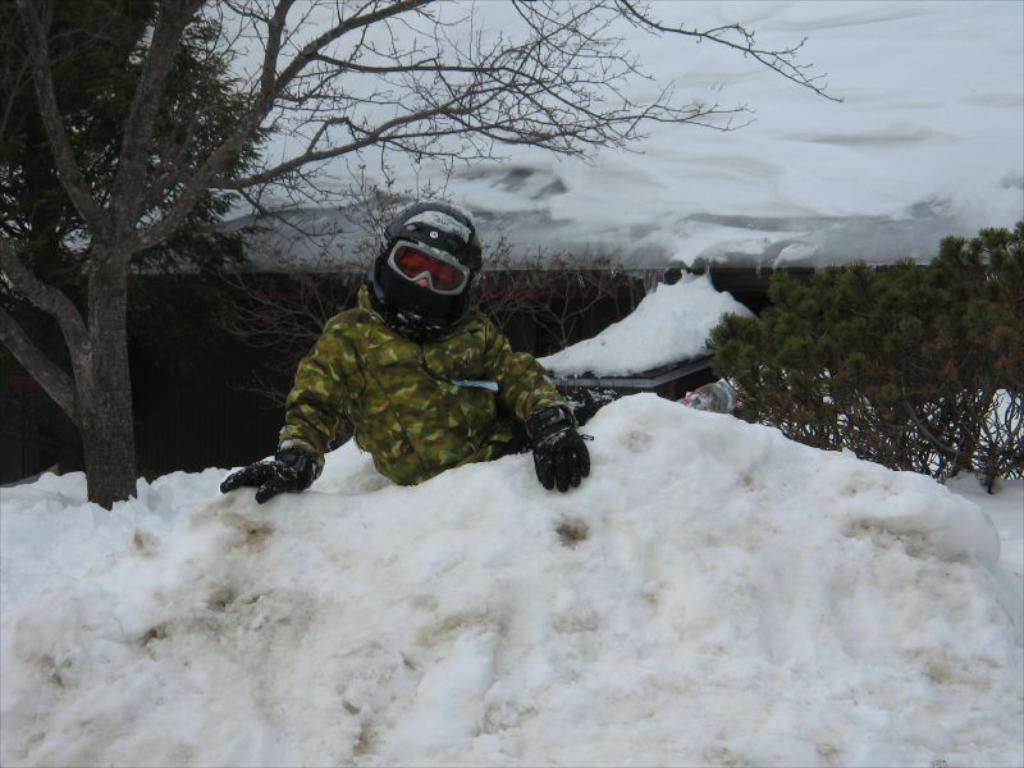What is the person in the image standing on? The person is standing on the snow in the image. What type of vegetation can be seen in the image? There are trees in the image. What is visible in the background of the image? The sky is visible in the image. What can be observed in the sky? Clouds are present in the sky. What is the person's annual income in the image? There is no information about the person's income in the image. What type of nut can be seen growing on the trees in the image? There are no nuts visible on the trees in the image; only the trees themselves are present. 